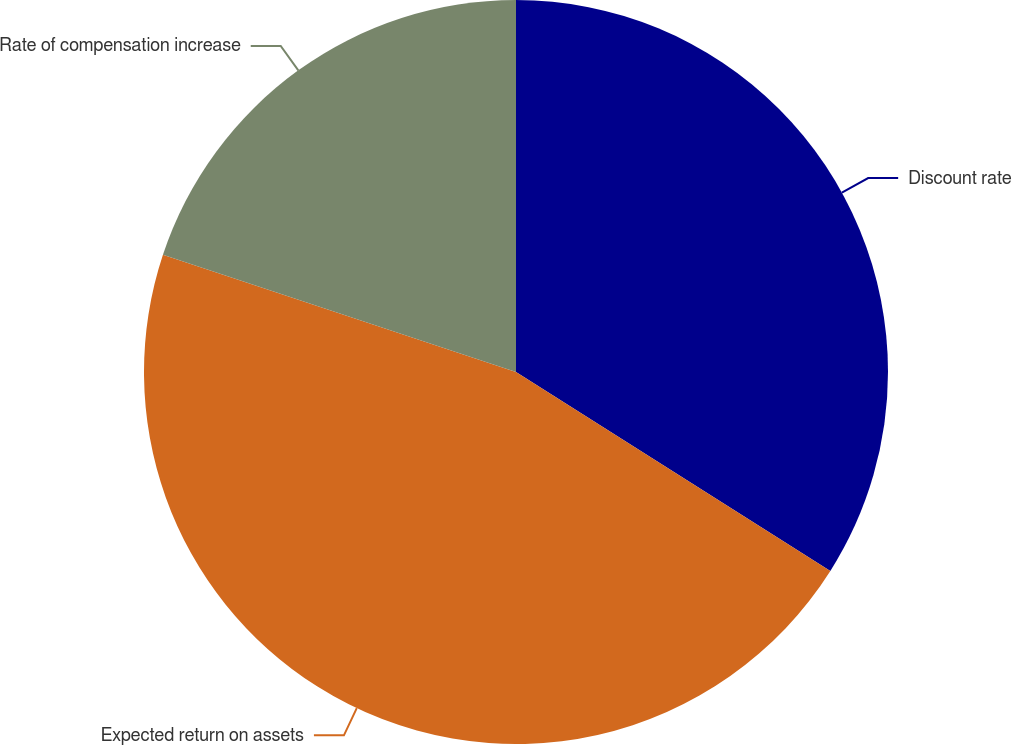<chart> <loc_0><loc_0><loc_500><loc_500><pie_chart><fcel>Discount rate<fcel>Expected return on assets<fcel>Rate of compensation increase<nl><fcel>33.98%<fcel>46.12%<fcel>19.9%<nl></chart> 